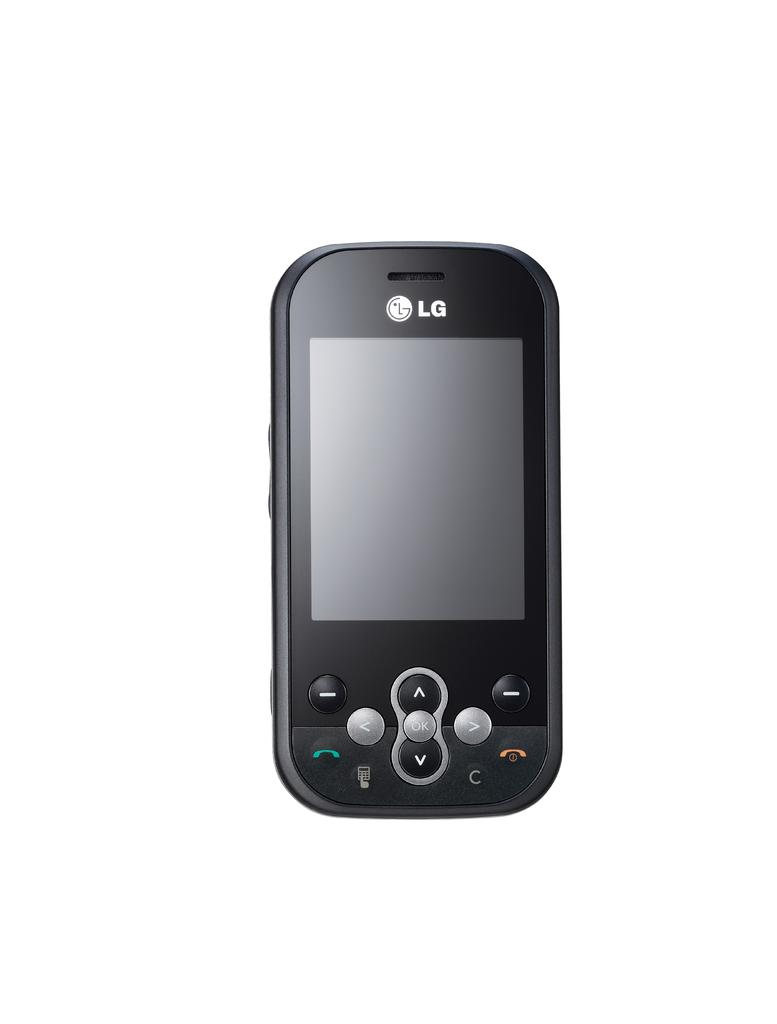What electronic device is visible in the image? There is a mobile phone in the image. What features can be seen on the mobile phone? The mobile phone has buttons, a speaker, and a screen. What is the color of the background in the image? The background of the image is white. What type of wine is being poured into the glass in the image? There is no glass or wine present in the image; it features a mobile phone with buttons, a speaker, and a screen against a white background. 